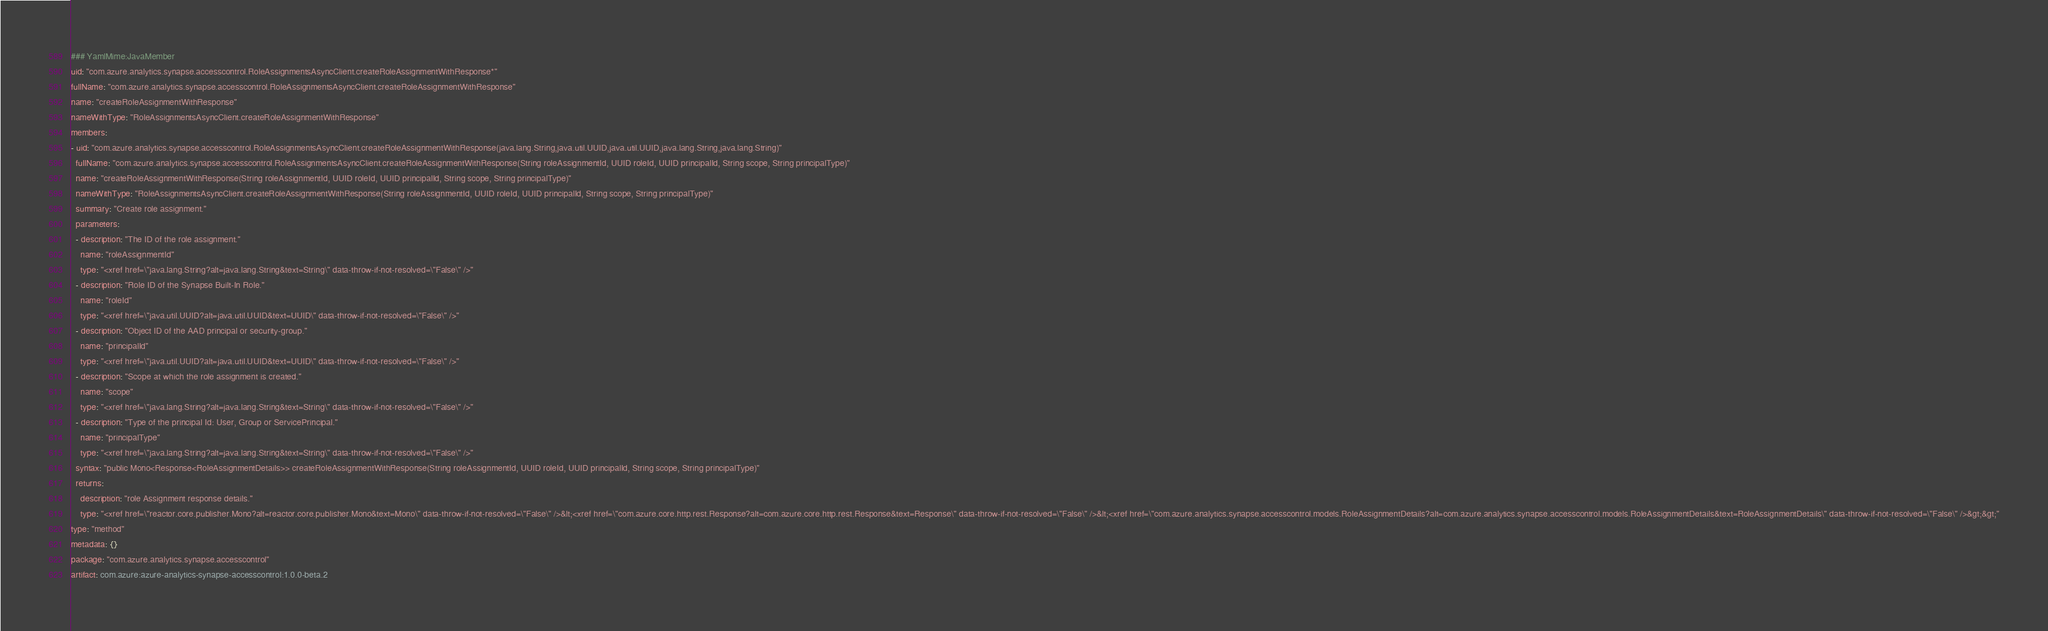<code> <loc_0><loc_0><loc_500><loc_500><_YAML_>### YamlMime:JavaMember
uid: "com.azure.analytics.synapse.accesscontrol.RoleAssignmentsAsyncClient.createRoleAssignmentWithResponse*"
fullName: "com.azure.analytics.synapse.accesscontrol.RoleAssignmentsAsyncClient.createRoleAssignmentWithResponse"
name: "createRoleAssignmentWithResponse"
nameWithType: "RoleAssignmentsAsyncClient.createRoleAssignmentWithResponse"
members:
- uid: "com.azure.analytics.synapse.accesscontrol.RoleAssignmentsAsyncClient.createRoleAssignmentWithResponse(java.lang.String,java.util.UUID,java.util.UUID,java.lang.String,java.lang.String)"
  fullName: "com.azure.analytics.synapse.accesscontrol.RoleAssignmentsAsyncClient.createRoleAssignmentWithResponse(String roleAssignmentId, UUID roleId, UUID principalId, String scope, String principalType)"
  name: "createRoleAssignmentWithResponse(String roleAssignmentId, UUID roleId, UUID principalId, String scope, String principalType)"
  nameWithType: "RoleAssignmentsAsyncClient.createRoleAssignmentWithResponse(String roleAssignmentId, UUID roleId, UUID principalId, String scope, String principalType)"
  summary: "Create role assignment."
  parameters:
  - description: "The ID of the role assignment."
    name: "roleAssignmentId"
    type: "<xref href=\"java.lang.String?alt=java.lang.String&text=String\" data-throw-if-not-resolved=\"False\" />"
  - description: "Role ID of the Synapse Built-In Role."
    name: "roleId"
    type: "<xref href=\"java.util.UUID?alt=java.util.UUID&text=UUID\" data-throw-if-not-resolved=\"False\" />"
  - description: "Object ID of the AAD principal or security-group."
    name: "principalId"
    type: "<xref href=\"java.util.UUID?alt=java.util.UUID&text=UUID\" data-throw-if-not-resolved=\"False\" />"
  - description: "Scope at which the role assignment is created."
    name: "scope"
    type: "<xref href=\"java.lang.String?alt=java.lang.String&text=String\" data-throw-if-not-resolved=\"False\" />"
  - description: "Type of the principal Id: User, Group or ServicePrincipal."
    name: "principalType"
    type: "<xref href=\"java.lang.String?alt=java.lang.String&text=String\" data-throw-if-not-resolved=\"False\" />"
  syntax: "public Mono<Response<RoleAssignmentDetails>> createRoleAssignmentWithResponse(String roleAssignmentId, UUID roleId, UUID principalId, String scope, String principalType)"
  returns:
    description: "role Assignment response details."
    type: "<xref href=\"reactor.core.publisher.Mono?alt=reactor.core.publisher.Mono&text=Mono\" data-throw-if-not-resolved=\"False\" />&lt;<xref href=\"com.azure.core.http.rest.Response?alt=com.azure.core.http.rest.Response&text=Response\" data-throw-if-not-resolved=\"False\" />&lt;<xref href=\"com.azure.analytics.synapse.accesscontrol.models.RoleAssignmentDetails?alt=com.azure.analytics.synapse.accesscontrol.models.RoleAssignmentDetails&text=RoleAssignmentDetails\" data-throw-if-not-resolved=\"False\" />&gt;&gt;"
type: "method"
metadata: {}
package: "com.azure.analytics.synapse.accesscontrol"
artifact: com.azure:azure-analytics-synapse-accesscontrol:1.0.0-beta.2
</code> 